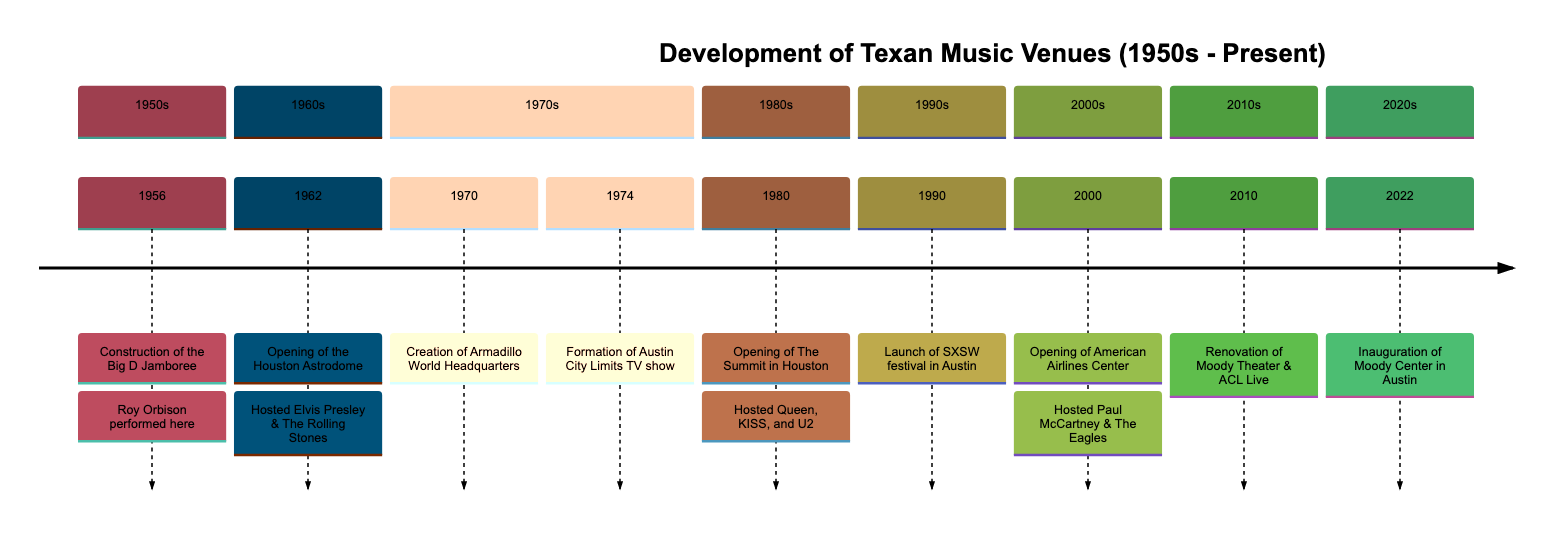What's the first event listed in the timeline? The timeline starts with the event that occurred in 1956, which is the construction of the Big D Jamboree.
Answer: Construction of the Big D Jamboree Which famous artist performed at the Big D Jamboree? The event description states that Roy Orbison performed at the Big D Jamboree, making him closely associated with this venue.
Answer: Roy Orbison How many events occurred in the 1970s section of the timeline? The timeline for the 1970s includes two events: the creation of Armadillo World Headquarters in 1970 and the formation of Austin City Limits TV show in 1974. Therefore, the count is two.
Answer: 2 What year did the Austin City Limits TV show begin? From the timeline data, the event describing the formation of the Austin City Limits TV show indicates that it was established in 1974.
Answer: 1974 Which venue is known as "The Eighth Wonder of the World"? The timeline states that the Houston Astrodome was dubbed "The Eighth Wonder of the World" upon its opening in 1962.
Answer: Houston Astrodome What significant event happened in Austin in 1990? The launch of the South by Southwest (SXSW) festival in Austin is mentioned as the significant event for that year in the timeline.
Answer: Launch of SXSW festival Which venue opened in Dallas in 2000? According to the timeline, the American Airlines Center opened in Dallas in the year 2000.
Answer: American Airlines Center What major renovation occurred in 2010? The renovation of the Moody Theater and the establishment of ACL Live is identified as a significant event in 2010 according to the timeline.
Answer: Renovation of the Moody Theater What new venue was inaugurated in Austin in 2022? Based on the last entry in the timeline, the Moody Center was inaugurated in Austin in 2022, marking the latest development in music venues.
Answer: Moody Center 